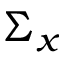Convert formula to latex. <formula><loc_0><loc_0><loc_500><loc_500>\Sigma _ { x }</formula> 